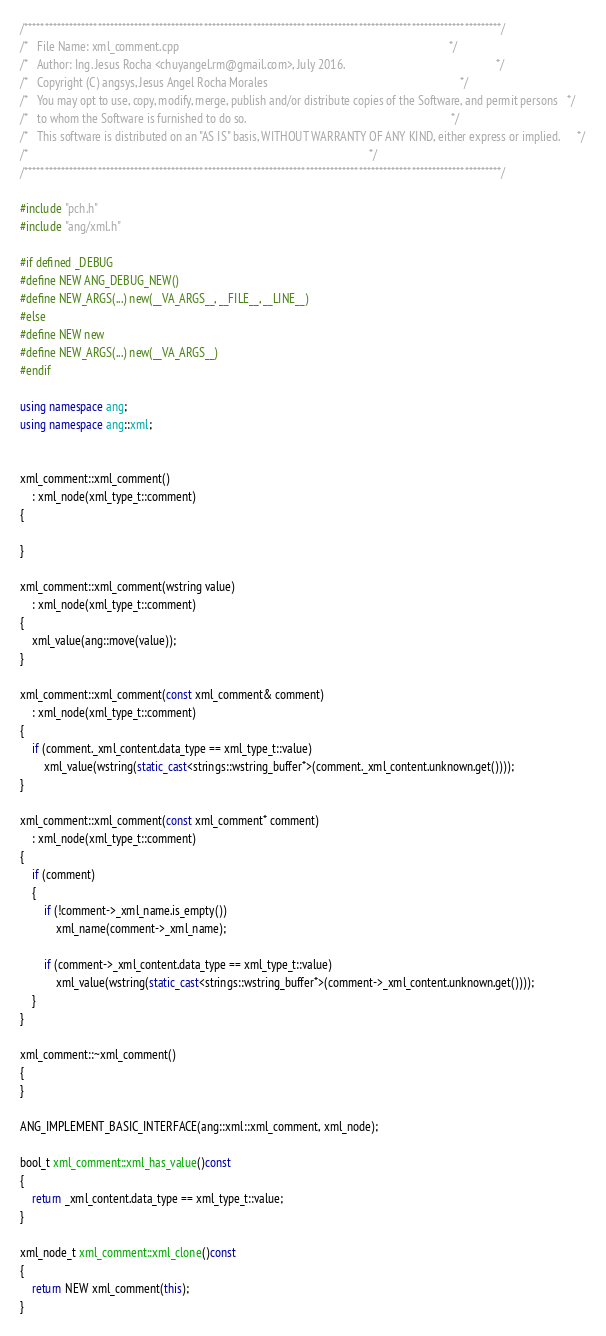<code> <loc_0><loc_0><loc_500><loc_500><_C++_>/*********************************************************************************************************************/
/*   File Name: xml_comment.cpp                                                                                           */
/*   Author: Ing. Jesus Rocha <chuyangel.rm@gmail.com>, July 2016.                                                   */
/*   Copyright (C) angsys, Jesus Angel Rocha Morales                                                                 */
/*   You may opt to use, copy, modify, merge, publish and/or distribute copies of the Software, and permit persons   */
/*   to whom the Software is furnished to do so.                                                                     */
/*   This software is distributed on an "AS IS" basis, WITHOUT WARRANTY OF ANY KIND, either express or implied.      */
/*                                                                                                                   */
/*********************************************************************************************************************/

#include "pch.h"
#include "ang/xml.h"

#if defined _DEBUG
#define NEW ANG_DEBUG_NEW()
#define NEW_ARGS(...) new(__VA_ARGS__, __FILE__, __LINE__)
#else
#define NEW new
#define NEW_ARGS(...) new(__VA_ARGS__)
#endif

using namespace ang;
using namespace ang::xml;


xml_comment::xml_comment()
	: xml_node(xml_type_t::comment)
{

}

xml_comment::xml_comment(wstring value)
	: xml_node(xml_type_t::comment)
{
	xml_value(ang::move(value));
}

xml_comment::xml_comment(const xml_comment& comment)
	: xml_node(xml_type_t::comment)
{
	if (comment._xml_content.data_type == xml_type_t::value)
		xml_value(wstring(static_cast<strings::wstring_buffer*>(comment._xml_content.unknown.get())));
}

xml_comment::xml_comment(const xml_comment* comment)
	: xml_node(xml_type_t::comment)
{
	if (comment)
	{
		if (!comment->_xml_name.is_empty())
			xml_name(comment->_xml_name);

		if (comment->_xml_content.data_type == xml_type_t::value)
			xml_value(wstring(static_cast<strings::wstring_buffer*>(comment->_xml_content.unknown.get())));
	}
}

xml_comment::~xml_comment()
{
}

ANG_IMPLEMENT_BASIC_INTERFACE(ang::xml::xml_comment, xml_node);

bool_t xml_comment::xml_has_value()const
{
	return _xml_content.data_type == xml_type_t::value;
}

xml_node_t xml_comment::xml_clone()const
{
	return NEW xml_comment(this);
}</code> 